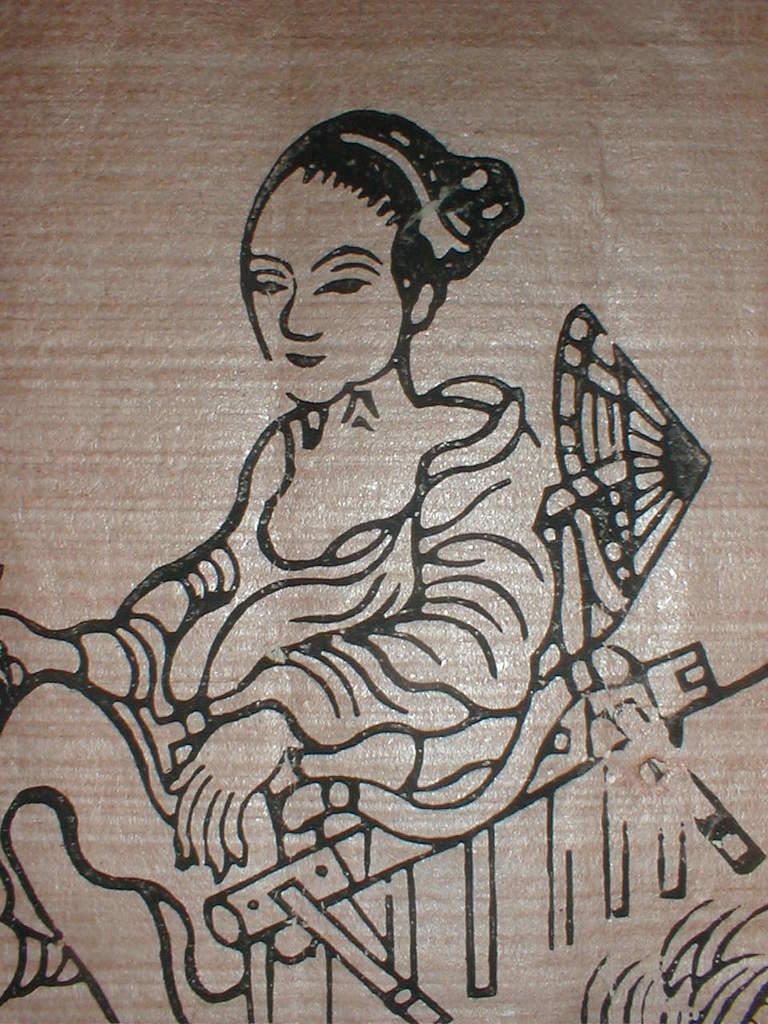How would you summarize this image in a sentence or two? In this image I can see the persons art on the brown color surface. I can see the art of the person. 